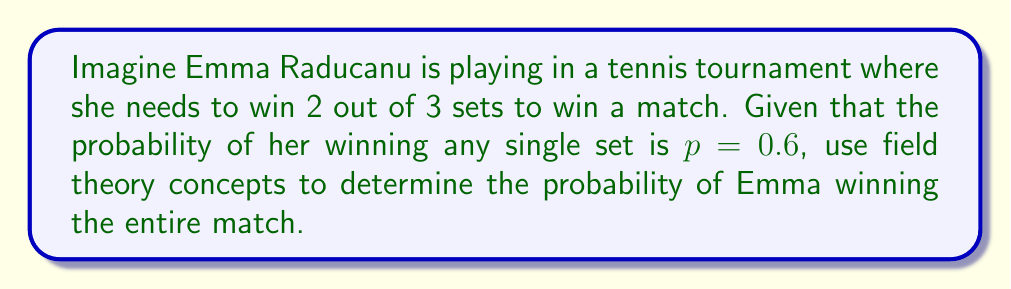Could you help me with this problem? Let's approach this step-by-step using field theory concepts:

1) First, we need to identify the sample space. In this case, it's the set of all possible outcomes of the match. Let's represent winning a set as 1 and losing a set as 0.

2) The possible winning combinations for Emma are:
   - Win-Win (11)
   - Win-Lose-Win (101)
   - Lose-Win-Win (011)

3) Now, let's consider the field $F_2 = \{0, 1\}$ with addition and multiplication modulo 2. Each match outcome can be represented as an element in the vector space $F_2^3$.

4) The probability of each outcome can be calculated using the given probability $p = 0.6$:

   $P(11) = p^2 = 0.6^2 = 0.36$
   $P(101) = P(011) = p^2(1-p) = 0.6^2 * 0.4 = 0.144$

5) The total probability of winning is the sum of these probabilities:

   $P(\text{Emma wins}) = P(11) + P(101) + P(011)$
   $= 0.36 + 0.144 + 0.144$
   $= 0.648$

6) We can verify this result using the general formula for a best-of-3 match:

   $P(\text{winning match}) = p^2 + 2p^2(1-p)$
   $= 0.6^2 + 2(0.6^2)(0.4)$
   $= 0.36 + 0.288$
   $= 0.648$

This approach uses the concept of vector spaces over finite fields (specifically $F_2$) to represent match outcomes, demonstrating how field theory can be applied to probability problems in sports.
Answer: $0.648$ 